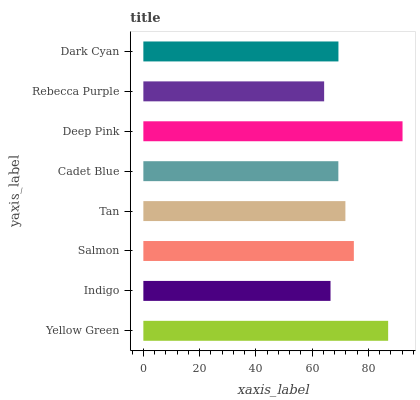Is Rebecca Purple the minimum?
Answer yes or no. Yes. Is Deep Pink the maximum?
Answer yes or no. Yes. Is Indigo the minimum?
Answer yes or no. No. Is Indigo the maximum?
Answer yes or no. No. Is Yellow Green greater than Indigo?
Answer yes or no. Yes. Is Indigo less than Yellow Green?
Answer yes or no. Yes. Is Indigo greater than Yellow Green?
Answer yes or no. No. Is Yellow Green less than Indigo?
Answer yes or no. No. Is Tan the high median?
Answer yes or no. Yes. Is Dark Cyan the low median?
Answer yes or no. Yes. Is Cadet Blue the high median?
Answer yes or no. No. Is Tan the low median?
Answer yes or no. No. 